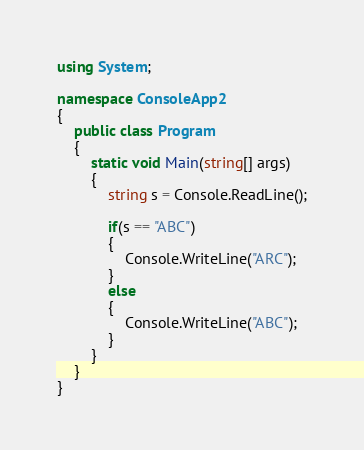<code> <loc_0><loc_0><loc_500><loc_500><_C#_>using System;

namespace ConsoleApp2
{
    public class Program
    {
        static void Main(string[] args)
        {
            string s = Console.ReadLine();

            if(s == "ABC")
            {
                Console.WriteLine("ARC");
            }
            else
            {
                Console.WriteLine("ABC");
            }
        }
    }
}
</code> 